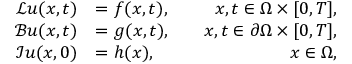<formula> <loc_0><loc_0><loc_500><loc_500>\begin{array} { r l r } { \mathcal { L } u ( x , t ) } & { = f ( x , t ) , } & { \quad x , t \in \Omega \times [ 0 , T ] , } \\ { \mathcal { B } u ( x , t ) } & { = g ( x , t ) , } & { \quad x , t \in \partial \Omega \times [ 0 , T ] , } \\ { \mathcal { I } u ( x , 0 ) } & { = h ( x ) , } & { \quad x \in \Omega , } \end{array}</formula> 